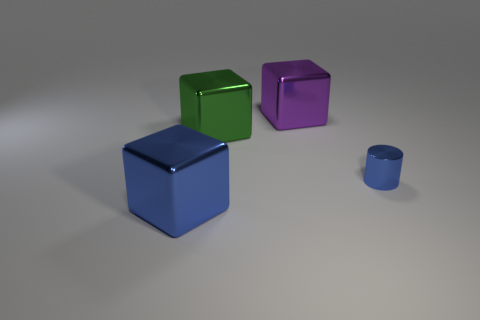Add 3 tiny green things. How many objects exist? 7 Subtract all purple metal cubes. How many cubes are left? 2 Subtract all green blocks. How many blocks are left? 2 Subtract all cylinders. How many objects are left? 3 Subtract 1 cubes. How many cubes are left? 2 Subtract all purple cylinders. Subtract all brown blocks. How many cylinders are left? 1 Subtract all small brown rubber balls. Subtract all large purple metallic cubes. How many objects are left? 3 Add 3 green blocks. How many green blocks are left? 4 Add 2 blue cubes. How many blue cubes exist? 3 Subtract 0 gray blocks. How many objects are left? 4 